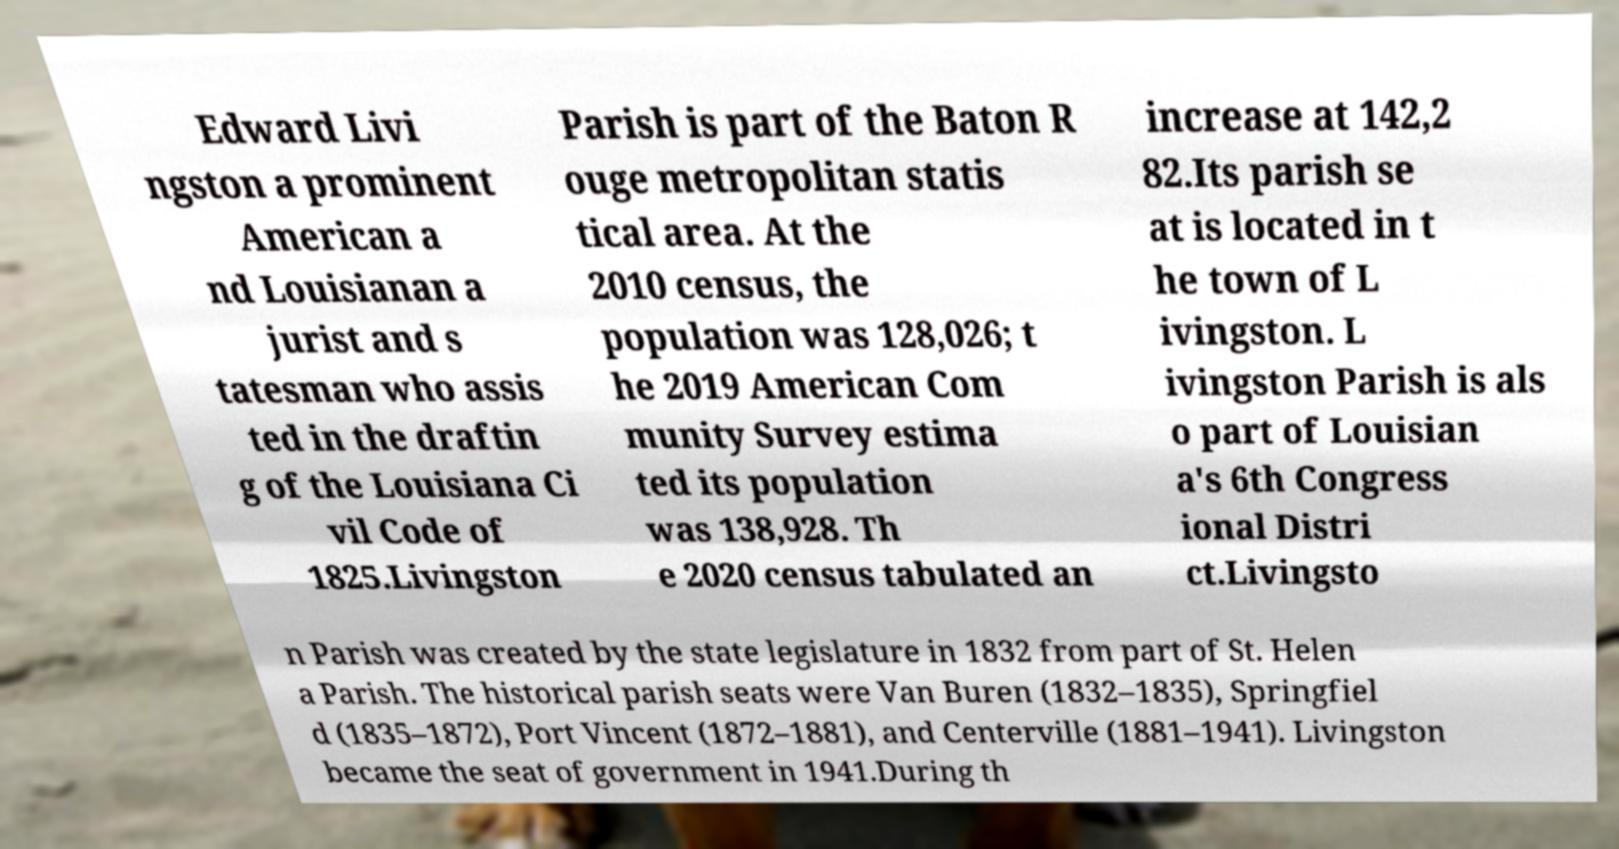What messages or text are displayed in this image? I need them in a readable, typed format. Edward Livi ngston a prominent American a nd Louisianan a jurist and s tatesman who assis ted in the draftin g of the Louisiana Ci vil Code of 1825.Livingston Parish is part of the Baton R ouge metropolitan statis tical area. At the 2010 census, the population was 128,026; t he 2019 American Com munity Survey estima ted its population was 138,928. Th e 2020 census tabulated an increase at 142,2 82.Its parish se at is located in t he town of L ivingston. L ivingston Parish is als o part of Louisian a's 6th Congress ional Distri ct.Livingsto n Parish was created by the state legislature in 1832 from part of St. Helen a Parish. The historical parish seats were Van Buren (1832–1835), Springfiel d (1835–1872), Port Vincent (1872–1881), and Centerville (1881–1941). Livingston became the seat of government in 1941.During th 